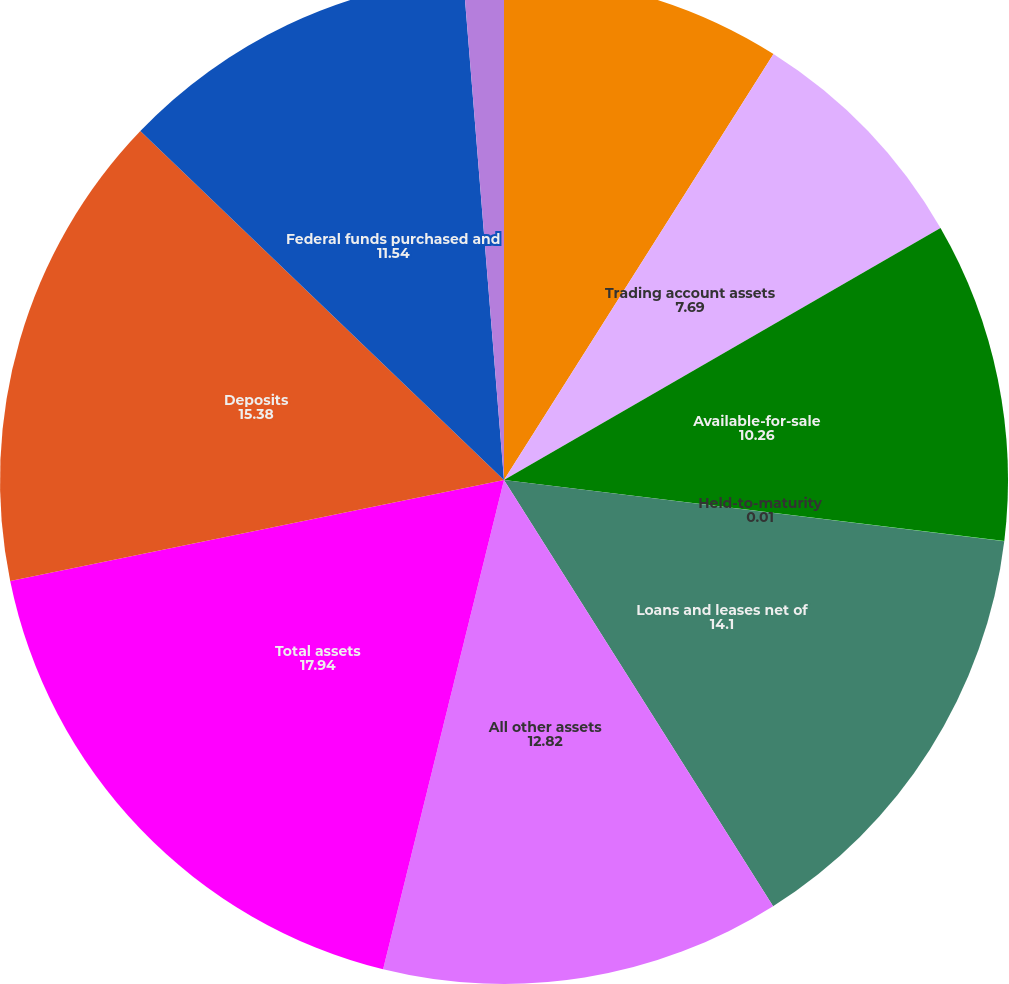Convert chart to OTSL. <chart><loc_0><loc_0><loc_500><loc_500><pie_chart><fcel>Federal funds sold and<fcel>Trading account assets<fcel>Available-for-sale<fcel>Held-to-maturity<fcel>Loans and leases net of<fcel>All other assets<fcel>Total assets<fcel>Deposits<fcel>Federal funds purchased and<fcel>Trading account liabilities<nl><fcel>8.98%<fcel>7.69%<fcel>10.26%<fcel>0.01%<fcel>14.1%<fcel>12.82%<fcel>17.94%<fcel>15.38%<fcel>11.54%<fcel>1.29%<nl></chart> 